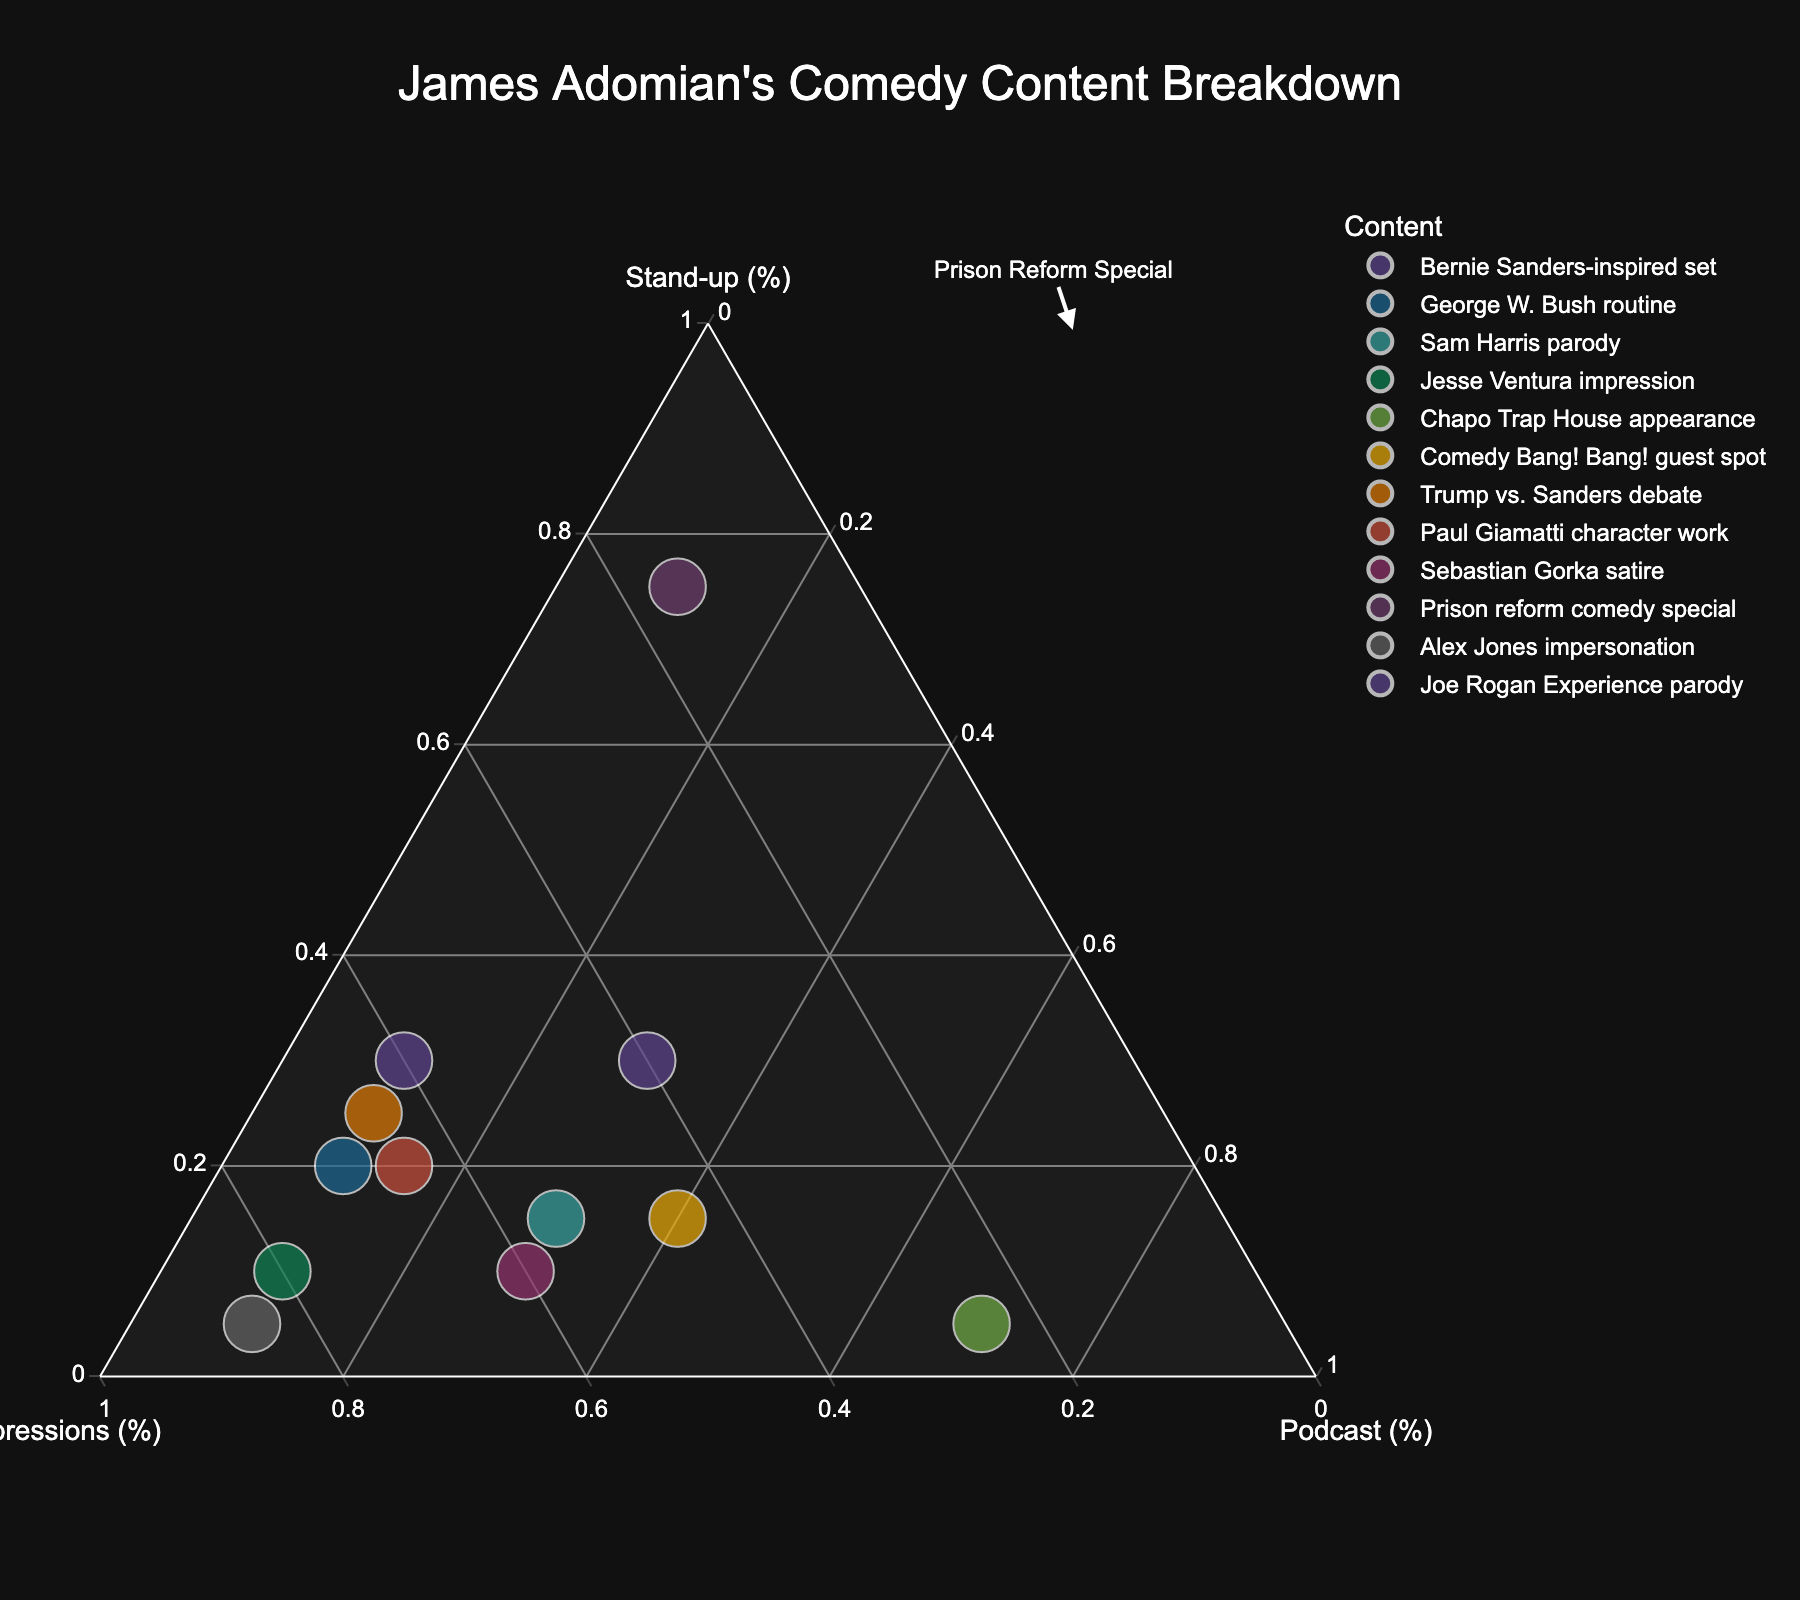What is the title of the figure? The title is located at the top center of the figure. It is meant to give a brief description of what the figure is about.
Answer: James Adomian's Comedy Content Breakdown How many data points are plotted in the figure? Count the number of distinct content labels that appear in the hover popups or in the legend of the figure. There are 12 content labels, so there are 12 data points.
Answer: 12 Which content has the highest percentage of podcast appearances? Look for the data point closest to the "Podcast (%)" axis. The highest percentage of podcast appearances is "Chapo Trap House appearance" at 70%.
Answer: Chapo Trap House appearance Which content has the highest percentage of stand-up material? Look for the data point closest to the "Stand-up (%)" axis. The highest percentage of stand-up material is "Prison reform comedy special" at 75%.
Answer: Prison reform comedy special Which contents have equal percentages for stand-up and podcast appearances? Look at the data points and find the ones where the stand-up percentage equals the podcast percentage. In this case, "Sam Harris parody" and "Sebastian Gorka satire" each have a 30% podcast and 15% stand-up for the former, and 30% podcast and 10% stand-up for the latter.
Answer: None What is the most balanced content in terms of percentage across all three categories? Find the content that is closest to the center of the ternary plot. In this case, it would seem like "Joe Rogan Experience parody" which has reasonably balanced percentages: 30% stand-up, 40% impressions, and 30% podcast.
Answer: Joe Rogan Experience parody Which content is closest to the top apex (Impressions)? The content nearest the top apex, which represents the highest percentage of impressions, is "Alex Jones impersonation" at 85%.
Answer: Alex Jones impersonation What is the combined percentage of stand-up for "Trump vs. Sanders debate" and "Bernie Sanders-inspired set"? Add the percentage values for stand-up for both contents. Trump vs. Sanders debate is 25% and Bernie Sanders-inspired set is 30%. 25% + 30% = 55%.
Answer: 55% Is there any content with the exact same percentage breakdown for two categories? Review each data point’s percentages and check for matches across two categories. No data points have equal percentages across any two categories in this figure.
Answer: No Which content features the least amount of stand-up and impressions but the most podcast appearances? Look for the data point with the highest podcast percentage and the lowest stand-up and impressions percentages. The "Chapo Trap House appearance" has 5% stand-up, 25% impressions, and 70% podcast.
Answer: Chapo Trap House appearance 